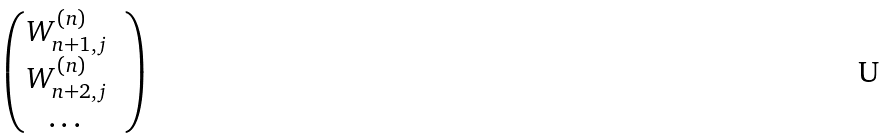<formula> <loc_0><loc_0><loc_500><loc_500>\begin{pmatrix} W ^ { ( n ) } _ { n + 1 , j } & \\ W ^ { ( n ) } _ { n + 2 , j } & \\ \dots & \end{pmatrix}</formula> 